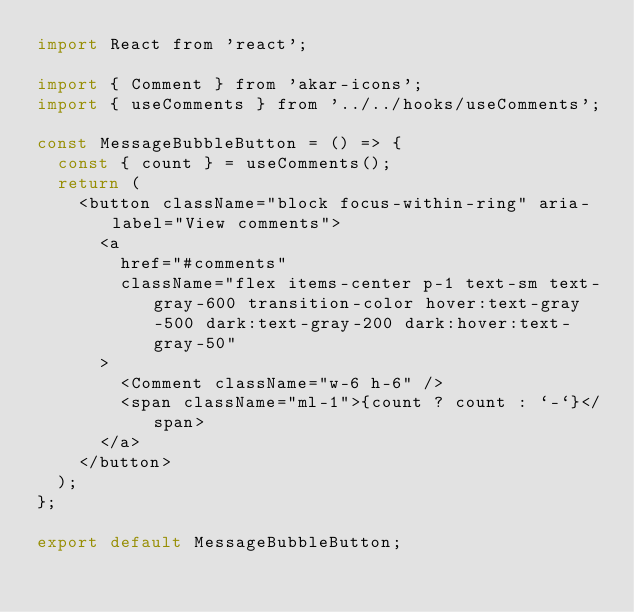Convert code to text. <code><loc_0><loc_0><loc_500><loc_500><_JavaScript_>import React from 'react';

import { Comment } from 'akar-icons';
import { useComments } from '../../hooks/useComments';

const MessageBubbleButton = () => {
  const { count } = useComments();
  return (
    <button className="block focus-within-ring" aria-label="View comments">
      <a
        href="#comments"
        className="flex items-center p-1 text-sm text-gray-600 transition-color hover:text-gray-500 dark:text-gray-200 dark:hover:text-gray-50"
      >
        <Comment className="w-6 h-6" />
        <span className="ml-1">{count ? count : `-`}</span>
      </a>
    </button>
  );
};

export default MessageBubbleButton;
</code> 